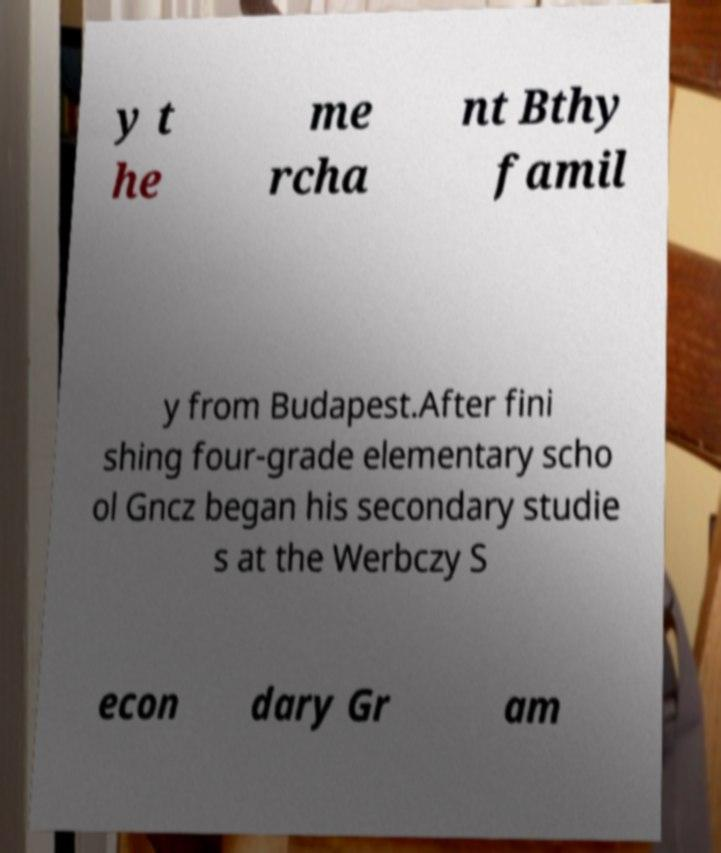There's text embedded in this image that I need extracted. Can you transcribe it verbatim? y t he me rcha nt Bthy famil y from Budapest.After fini shing four-grade elementary scho ol Gncz began his secondary studie s at the Werbczy S econ dary Gr am 